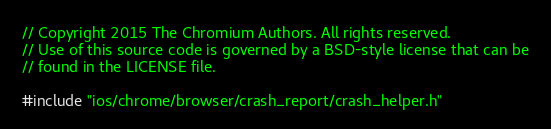Convert code to text. <code><loc_0><loc_0><loc_500><loc_500><_ObjectiveC_>// Copyright 2015 The Chromium Authors. All rights reserved.
// Use of this source code is governed by a BSD-style license that can be
// found in the LICENSE file.

#include "ios/chrome/browser/crash_report/crash_helper.h"
</code> 